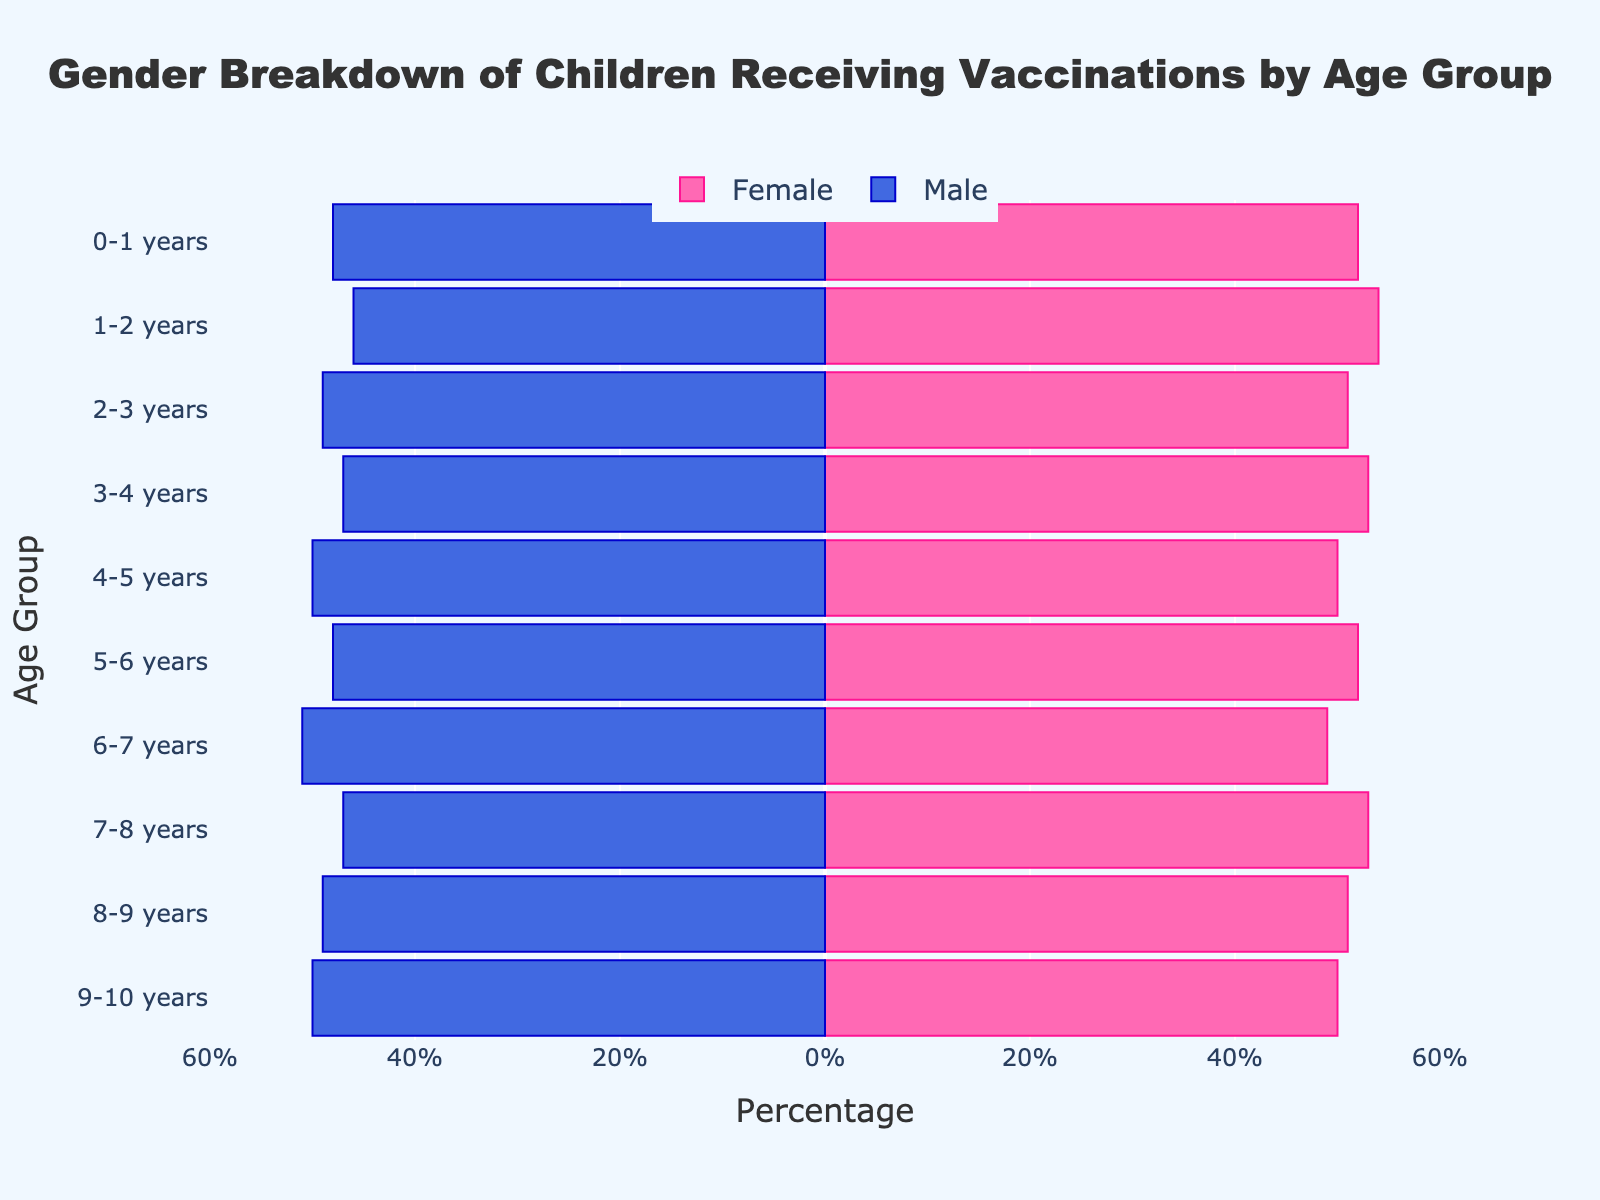What is the title of the figure? The figure's title is usually at the top of the plot. By looking at the top, we can identify the title text.
Answer: Gender Breakdown of Children Receiving Vaccinations by Age Group Which age group has an equal number of vaccinated males and females? Look for the age group where the length of the blue (Male) and pink (Female) bars are the same.
Answer: 4-5 years, 9-10 years In the 1-2 years age group, are there more vaccinated males or females? Compare the length of the pink (Female) bar with the blue (Male) bar for the 1-2 years age group. The pink bar is longer.
Answer: Females What is the most common age group for vaccinated males? Determine which age group has the longest blue bar representing males.
Answer: 6-7 years What is the least common age group for vaccinated females? Determine which age group has the shortest pink bar representing females.
Answer: 6-7 years What’s the difference in the number of vaccinated males and females in the 3-4 years age group? Subtract the value of the Male bar from the Female bar for the 3-4 years age group. Female: 53 - Male: 47 = 6
Answer: 6 How many age groups have more vaccinated females than males? Count the number of age groups where the pink bar (Female) is longer than the blue bar (Male).
Answer: 6 For the 7-8 years age group, which gender has more children vaccinated? By how much? Compare the length of the bars for both genders in this age group. The pink bar (Female) is longer. Subtract Male (47) from Female (53) = 6.
Answer: Females by 6 Which age group has the smallest difference between males and females in vaccination rates? Identify the age group where the blue and pink bars are nearly equal in length.
Answer: 4-5 years, 9-10 years How many total boys and girls of ages 0-1 years are vaccinated? Add the number of vaccinated boys and girls for the 0-1 years age group. Boys: 48 + Girls: 52 = 100
Answer: 100 